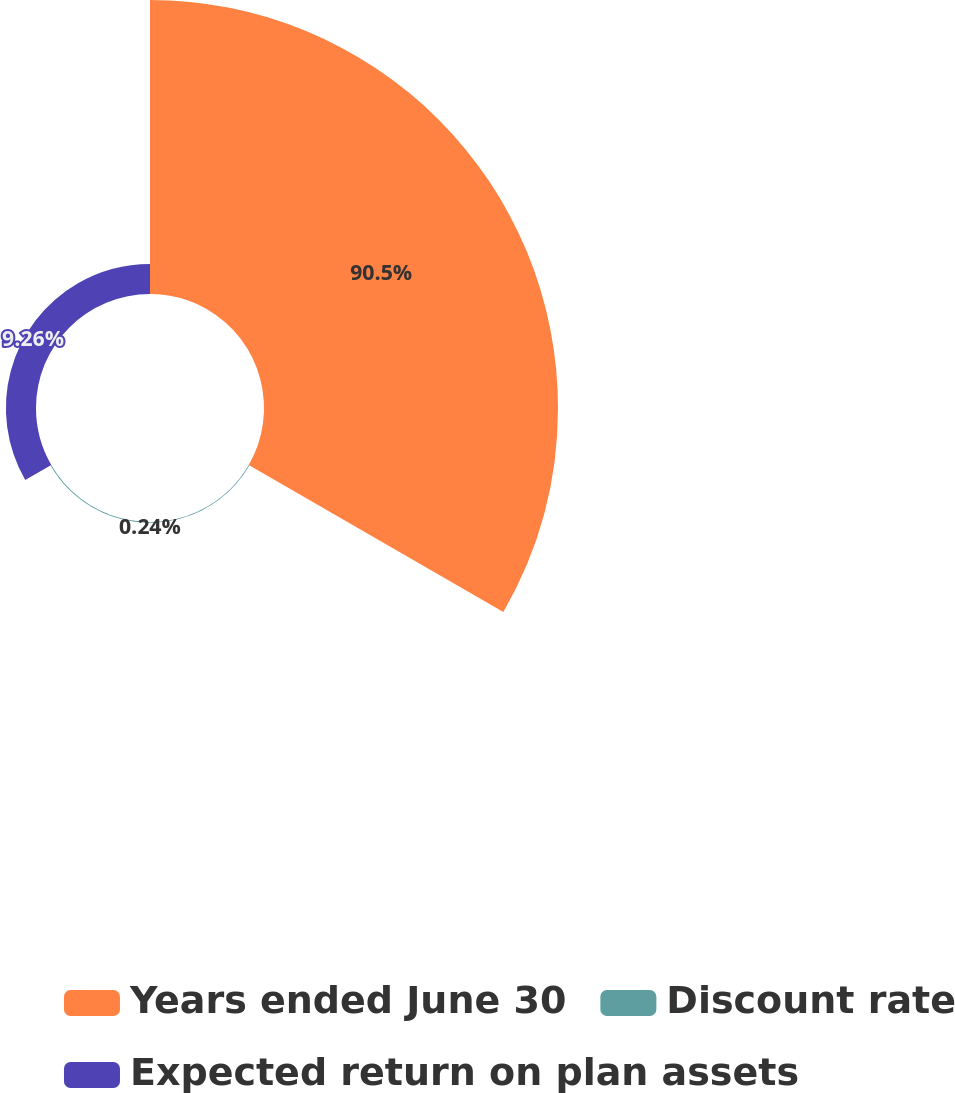Convert chart. <chart><loc_0><loc_0><loc_500><loc_500><pie_chart><fcel>Years ended June 30<fcel>Discount rate<fcel>Expected return on plan assets<nl><fcel>90.5%<fcel>0.24%<fcel>9.26%<nl></chart> 